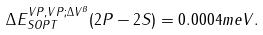<formula> <loc_0><loc_0><loc_500><loc_500>\Delta E _ { S O P T } ^ { V P , V P ; \Delta V ^ { B } } ( 2 P - 2 S ) = 0 . 0 0 0 4 m e V .</formula> 